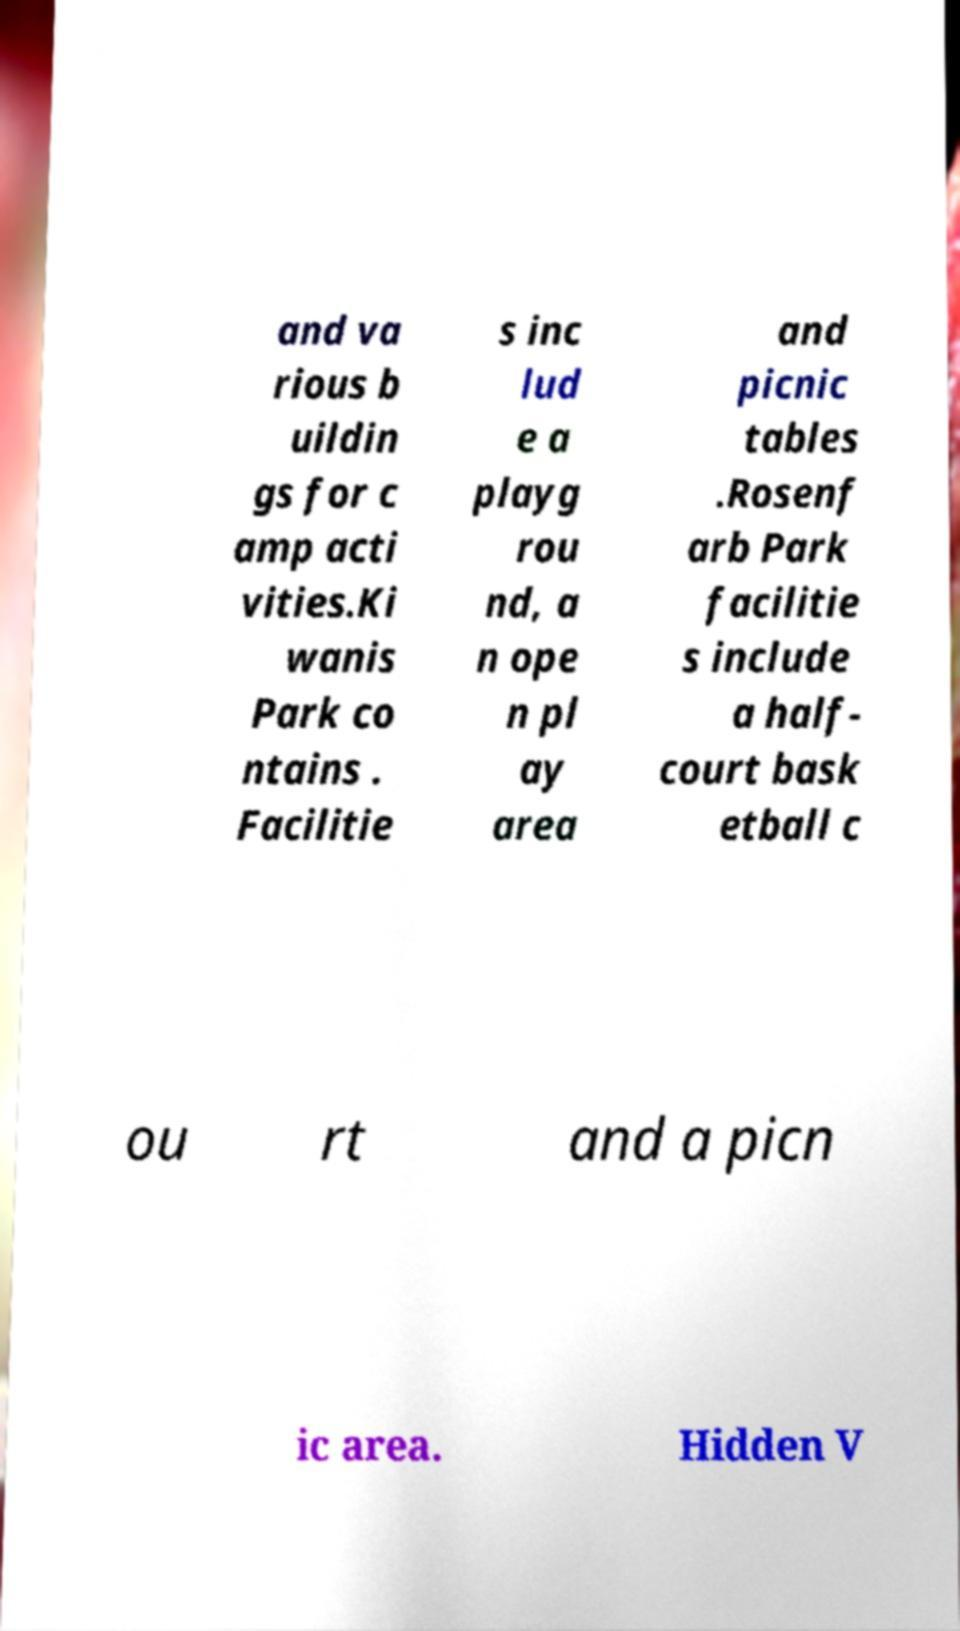For documentation purposes, I need the text within this image transcribed. Could you provide that? and va rious b uildin gs for c amp acti vities.Ki wanis Park co ntains . Facilitie s inc lud e a playg rou nd, a n ope n pl ay area and picnic tables .Rosenf arb Park facilitie s include a half- court bask etball c ou rt and a picn ic area. Hidden V 